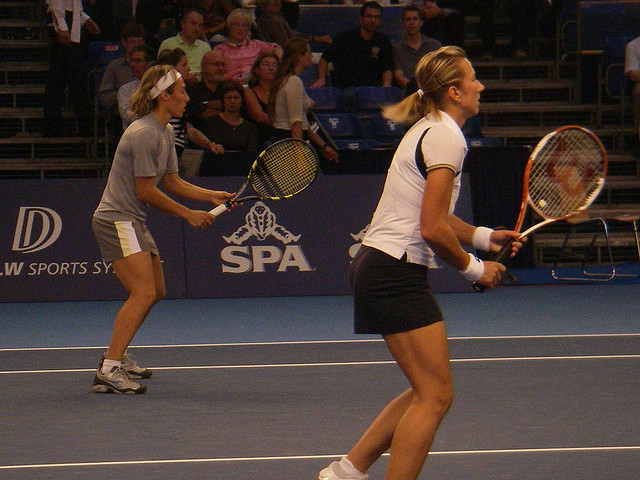What are the tennis players doing? The players are engaged in a doubles tennis match. The player in the foreground is preparing to hit the ball, while her partner is watching her back, ready to react. 